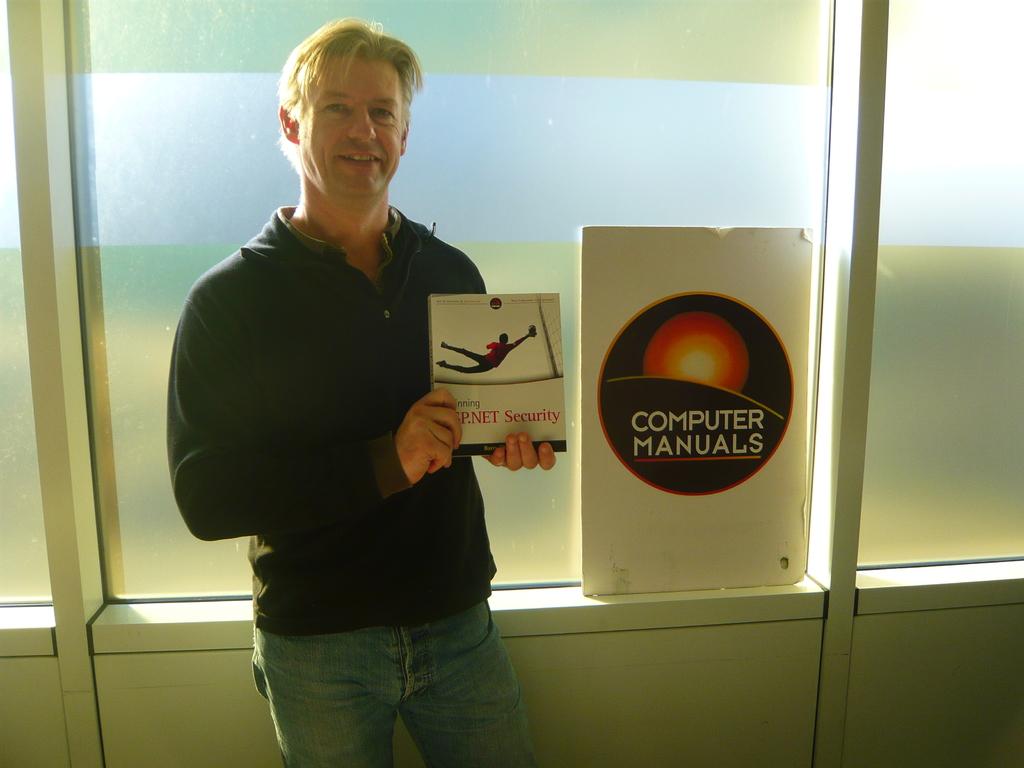What kind of manuals are advertised?
Provide a succinct answer. Computer. What is the word on the book he's holding?
Your answer should be very brief. Security. 